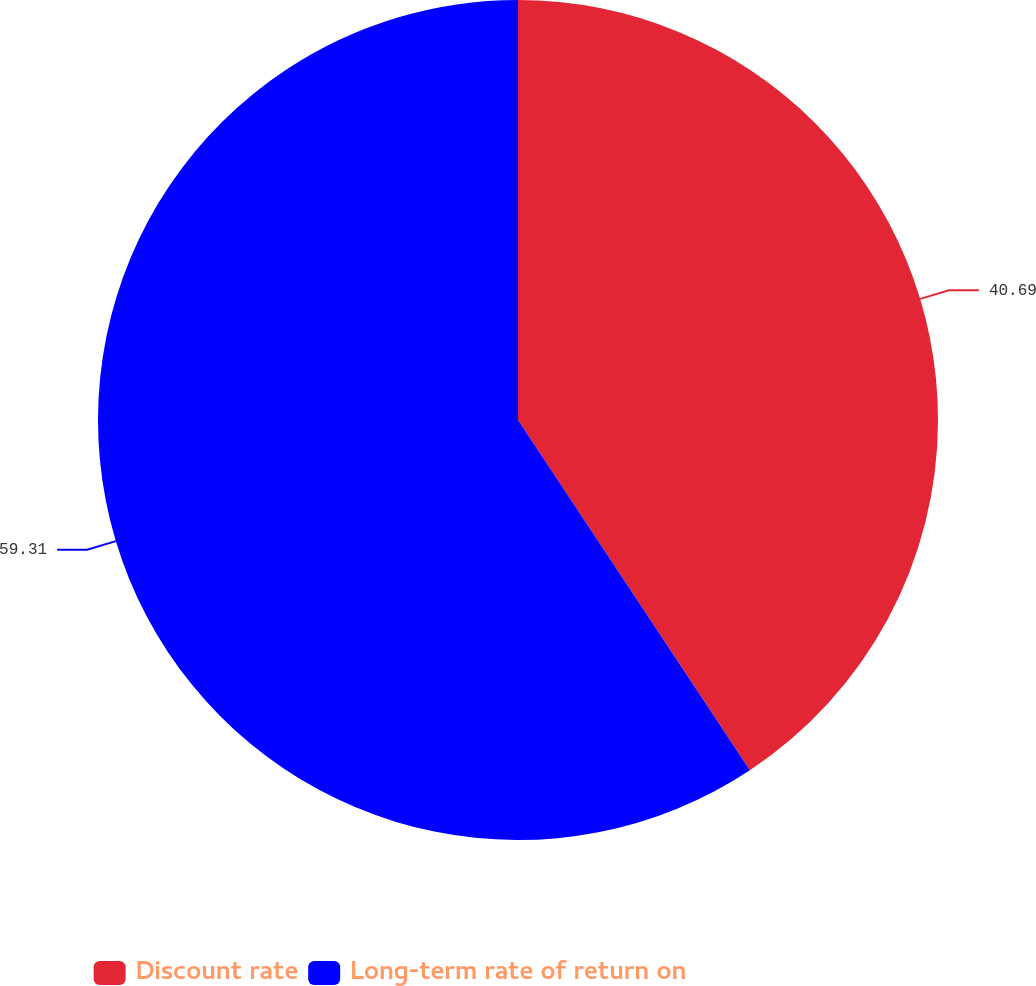<chart> <loc_0><loc_0><loc_500><loc_500><pie_chart><fcel>Discount rate<fcel>Long-term rate of return on<nl><fcel>40.69%<fcel>59.31%<nl></chart> 